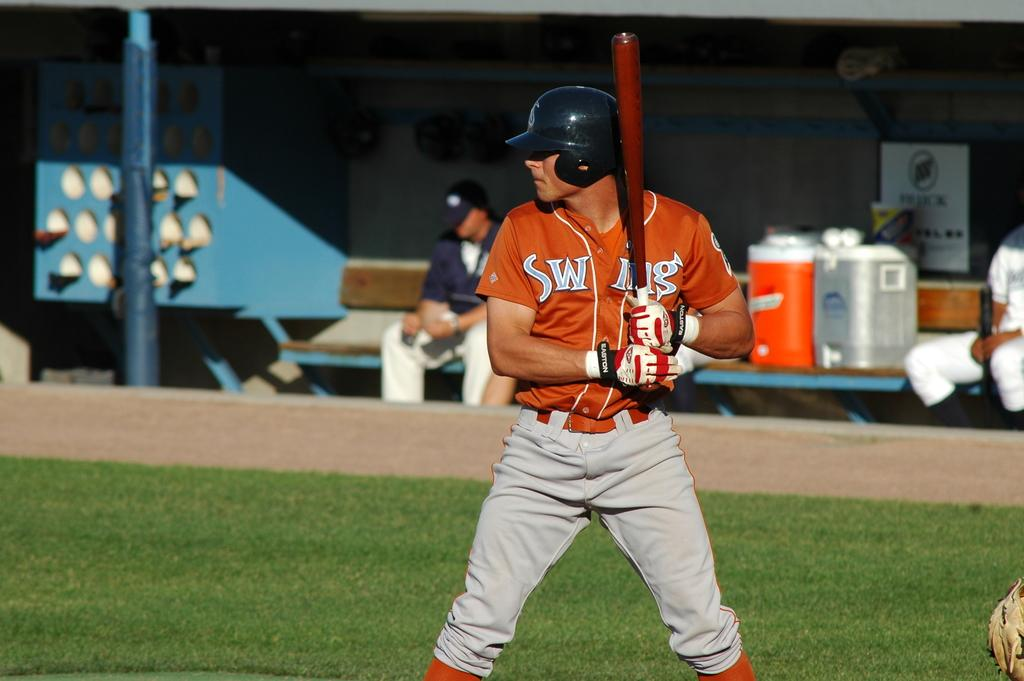Who or what can be seen in the image? There are people in the image. What is on the table in the image? There are objects on a table in the image. Can you describe the pole in the image? There is a pole in the image. What color is the blue object in the image? The blue colored object in the image is blue. What type of ground is visible in the image? The ground is covered with grass in the image. How many chickens are there in the image? There are no chickens present in the image. What type of frame surrounds the image? The image does not have a frame; it is a standalone image. 